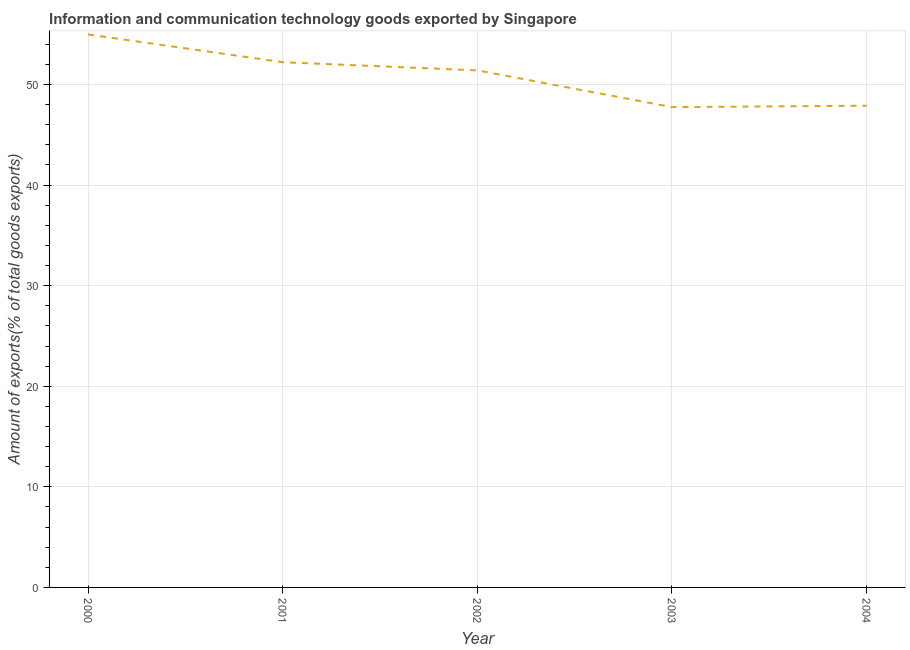What is the amount of ict goods exports in 2004?
Provide a succinct answer. 47.89. Across all years, what is the maximum amount of ict goods exports?
Provide a succinct answer. 54.97. Across all years, what is the minimum amount of ict goods exports?
Offer a very short reply. 47.75. In which year was the amount of ict goods exports maximum?
Provide a succinct answer. 2000. In which year was the amount of ict goods exports minimum?
Provide a short and direct response. 2003. What is the sum of the amount of ict goods exports?
Your response must be concise. 254.24. What is the difference between the amount of ict goods exports in 2002 and 2003?
Give a very brief answer. 3.65. What is the average amount of ict goods exports per year?
Give a very brief answer. 50.85. What is the median amount of ict goods exports?
Provide a succinct answer. 51.4. What is the ratio of the amount of ict goods exports in 2000 to that in 2001?
Give a very brief answer. 1.05. Is the amount of ict goods exports in 2001 less than that in 2004?
Your answer should be compact. No. What is the difference between the highest and the second highest amount of ict goods exports?
Your answer should be very brief. 2.76. Is the sum of the amount of ict goods exports in 2002 and 2004 greater than the maximum amount of ict goods exports across all years?
Make the answer very short. Yes. What is the difference between the highest and the lowest amount of ict goods exports?
Give a very brief answer. 7.22. How many lines are there?
Offer a terse response. 1. How many years are there in the graph?
Keep it short and to the point. 5. What is the difference between two consecutive major ticks on the Y-axis?
Offer a terse response. 10. Are the values on the major ticks of Y-axis written in scientific E-notation?
Keep it short and to the point. No. Does the graph contain grids?
Offer a terse response. Yes. What is the title of the graph?
Offer a terse response. Information and communication technology goods exported by Singapore. What is the label or title of the Y-axis?
Offer a terse response. Amount of exports(% of total goods exports). What is the Amount of exports(% of total goods exports) of 2000?
Your response must be concise. 54.97. What is the Amount of exports(% of total goods exports) of 2001?
Offer a terse response. 52.22. What is the Amount of exports(% of total goods exports) of 2002?
Your response must be concise. 51.4. What is the Amount of exports(% of total goods exports) in 2003?
Provide a short and direct response. 47.75. What is the Amount of exports(% of total goods exports) of 2004?
Your answer should be very brief. 47.89. What is the difference between the Amount of exports(% of total goods exports) in 2000 and 2001?
Keep it short and to the point. 2.76. What is the difference between the Amount of exports(% of total goods exports) in 2000 and 2002?
Offer a very short reply. 3.57. What is the difference between the Amount of exports(% of total goods exports) in 2000 and 2003?
Your answer should be very brief. 7.22. What is the difference between the Amount of exports(% of total goods exports) in 2000 and 2004?
Ensure brevity in your answer.  7.08. What is the difference between the Amount of exports(% of total goods exports) in 2001 and 2002?
Give a very brief answer. 0.81. What is the difference between the Amount of exports(% of total goods exports) in 2001 and 2003?
Keep it short and to the point. 4.47. What is the difference between the Amount of exports(% of total goods exports) in 2001 and 2004?
Your answer should be very brief. 4.33. What is the difference between the Amount of exports(% of total goods exports) in 2002 and 2003?
Keep it short and to the point. 3.65. What is the difference between the Amount of exports(% of total goods exports) in 2002 and 2004?
Your answer should be compact. 3.51. What is the difference between the Amount of exports(% of total goods exports) in 2003 and 2004?
Your answer should be compact. -0.14. What is the ratio of the Amount of exports(% of total goods exports) in 2000 to that in 2001?
Your response must be concise. 1.05. What is the ratio of the Amount of exports(% of total goods exports) in 2000 to that in 2002?
Make the answer very short. 1.07. What is the ratio of the Amount of exports(% of total goods exports) in 2000 to that in 2003?
Your answer should be compact. 1.15. What is the ratio of the Amount of exports(% of total goods exports) in 2000 to that in 2004?
Keep it short and to the point. 1.15. What is the ratio of the Amount of exports(% of total goods exports) in 2001 to that in 2002?
Keep it short and to the point. 1.02. What is the ratio of the Amount of exports(% of total goods exports) in 2001 to that in 2003?
Your answer should be compact. 1.09. What is the ratio of the Amount of exports(% of total goods exports) in 2001 to that in 2004?
Provide a short and direct response. 1.09. What is the ratio of the Amount of exports(% of total goods exports) in 2002 to that in 2003?
Keep it short and to the point. 1.08. What is the ratio of the Amount of exports(% of total goods exports) in 2002 to that in 2004?
Make the answer very short. 1.07. What is the ratio of the Amount of exports(% of total goods exports) in 2003 to that in 2004?
Provide a succinct answer. 1. 